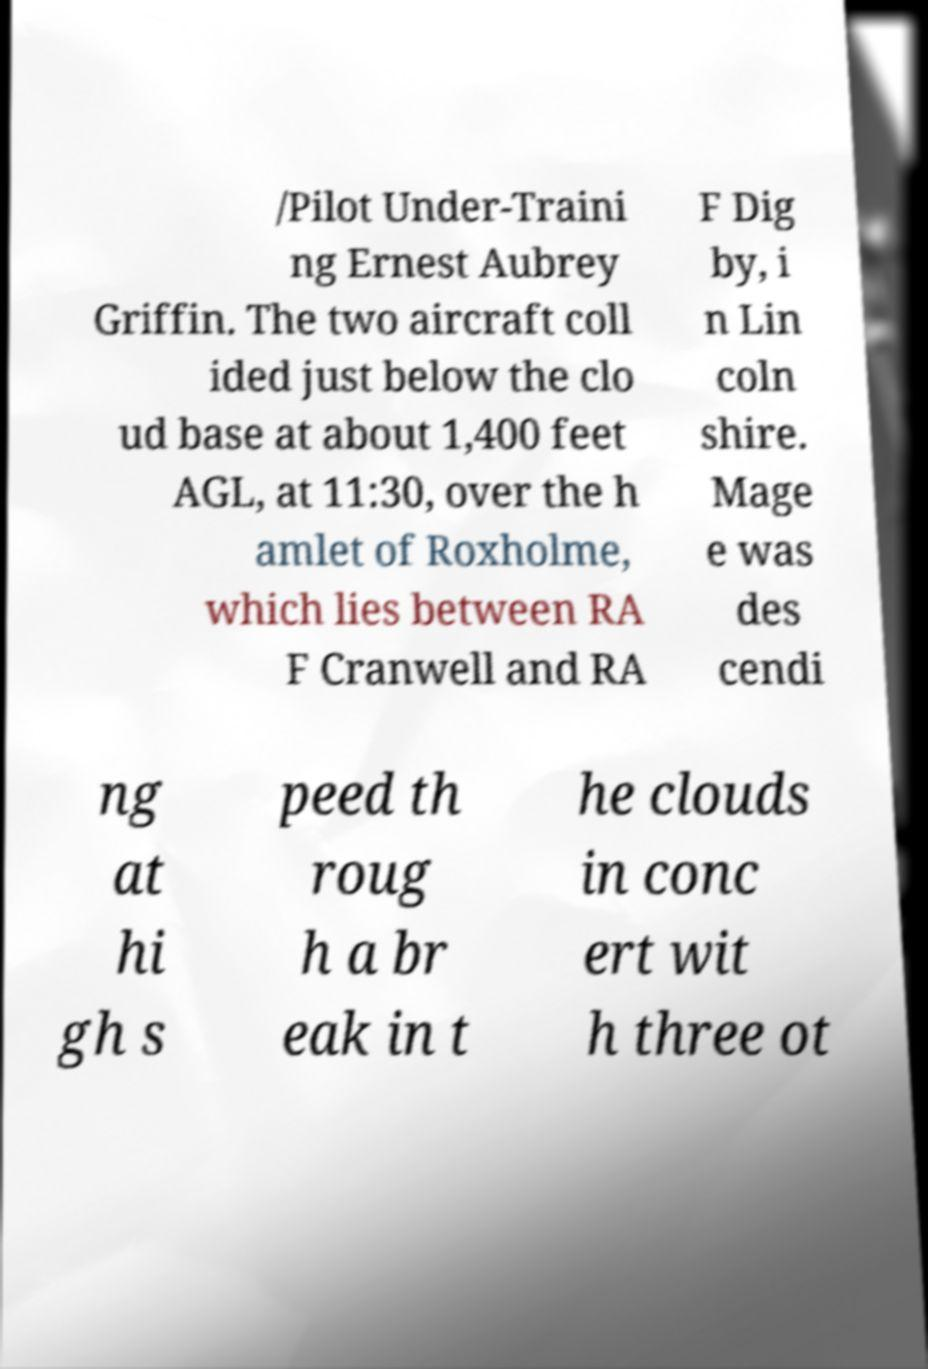What messages or text are displayed in this image? I need them in a readable, typed format. /Pilot Under-Traini ng Ernest Aubrey Griffin. The two aircraft coll ided just below the clo ud base at about 1,400 feet AGL, at 11:30, over the h amlet of Roxholme, which lies between RA F Cranwell and RA F Dig by, i n Lin coln shire. Mage e was des cendi ng at hi gh s peed th roug h a br eak in t he clouds in conc ert wit h three ot 